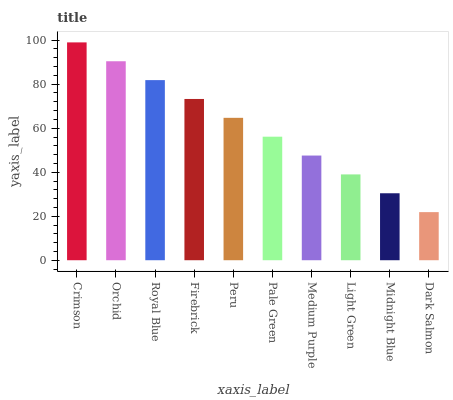Is Dark Salmon the minimum?
Answer yes or no. Yes. Is Crimson the maximum?
Answer yes or no. Yes. Is Orchid the minimum?
Answer yes or no. No. Is Orchid the maximum?
Answer yes or no. No. Is Crimson greater than Orchid?
Answer yes or no. Yes. Is Orchid less than Crimson?
Answer yes or no. Yes. Is Orchid greater than Crimson?
Answer yes or no. No. Is Crimson less than Orchid?
Answer yes or no. No. Is Peru the high median?
Answer yes or no. Yes. Is Pale Green the low median?
Answer yes or no. Yes. Is Dark Salmon the high median?
Answer yes or no. No. Is Firebrick the low median?
Answer yes or no. No. 